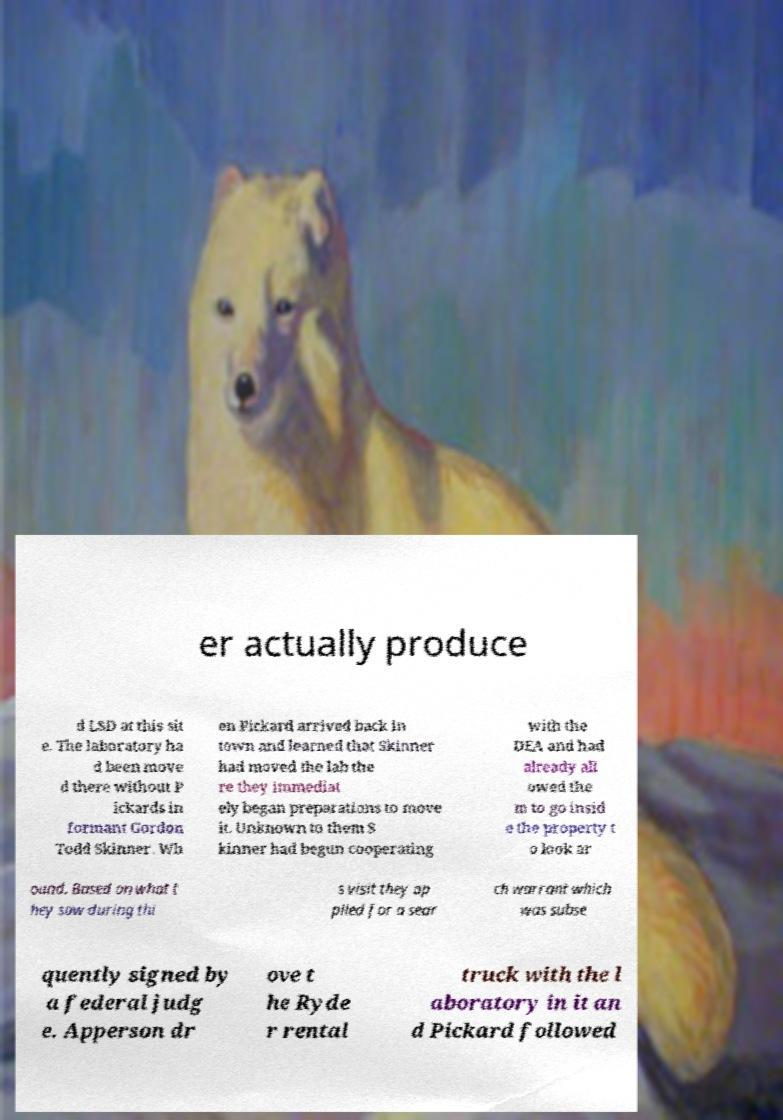Can you accurately transcribe the text from the provided image for me? er actually produce d LSD at this sit e. The laboratory ha d been move d there without P ickards in formant Gordon Todd Skinner. Wh en Pickard arrived back in town and learned that Skinner had moved the lab the re they immediat ely began preparations to move it. Unknown to them S kinner had begun cooperating with the DEA and had already all owed the m to go insid e the property t o look ar ound. Based on what t hey saw during thi s visit they ap plied for a sear ch warrant which was subse quently signed by a federal judg e. Apperson dr ove t he Ryde r rental truck with the l aboratory in it an d Pickard followed 